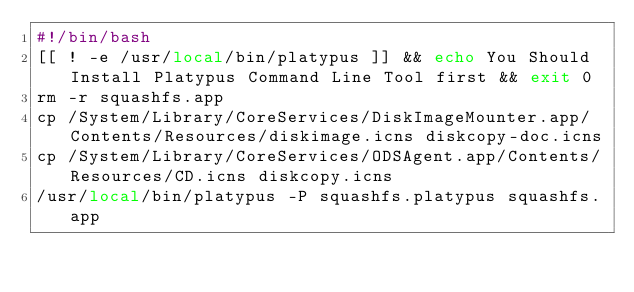Convert code to text. <code><loc_0><loc_0><loc_500><loc_500><_Bash_>#!/bin/bash
[[ ! -e /usr/local/bin/platypus ]] && echo You Should Install Platypus Command Line Tool first && exit 0
rm -r squashfs.app
cp /System/Library/CoreServices/DiskImageMounter.app/Contents/Resources/diskimage.icns diskcopy-doc.icns
cp /System/Library/CoreServices/ODSAgent.app/Contents/Resources/CD.icns diskcopy.icns
/usr/local/bin/platypus -P squashfs.platypus squashfs.app
</code> 